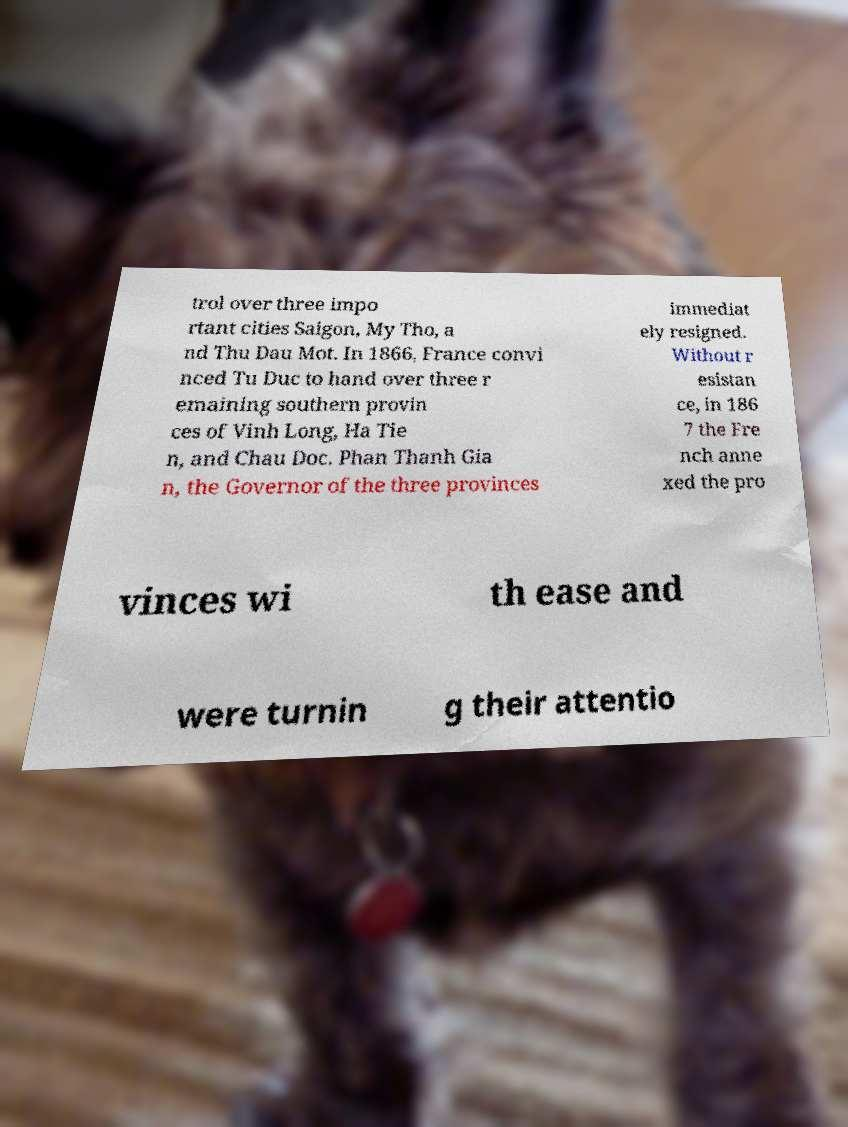Please read and relay the text visible in this image. What does it say? trol over three impo rtant cities Saigon, My Tho, a nd Thu Dau Mot. In 1866, France convi nced Tu Duc to hand over three r emaining southern provin ces of Vinh Long, Ha Tie n, and Chau Doc. Phan Thanh Gia n, the Governor of the three provinces immediat ely resigned. Without r esistan ce, in 186 7 the Fre nch anne xed the pro vinces wi th ease and were turnin g their attentio 